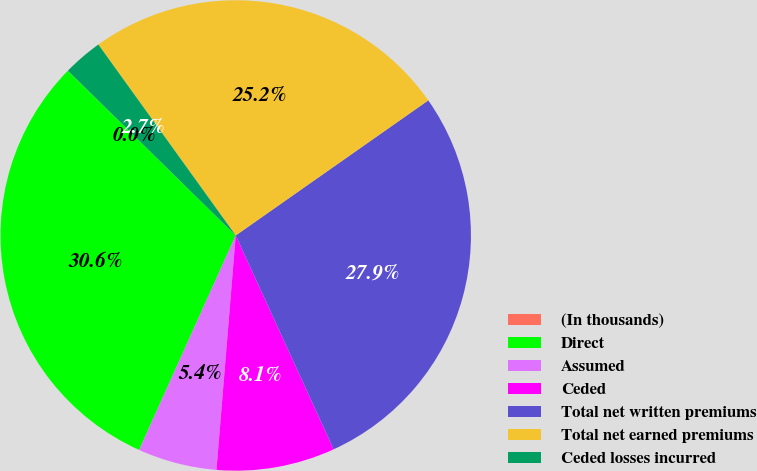Convert chart. <chart><loc_0><loc_0><loc_500><loc_500><pie_chart><fcel>(In thousands)<fcel>Direct<fcel>Assumed<fcel>Ceded<fcel>Total net written premiums<fcel>Total net earned premiums<fcel>Ceded losses incurred<nl><fcel>0.01%<fcel>30.61%<fcel>5.43%<fcel>8.14%<fcel>27.9%<fcel>25.19%<fcel>2.72%<nl></chart> 